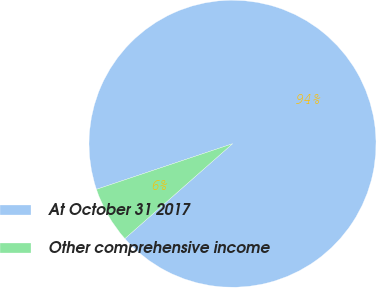Convert chart. <chart><loc_0><loc_0><loc_500><loc_500><pie_chart><fcel>At October 31 2017<fcel>Other comprehensive income<nl><fcel>93.65%<fcel>6.35%<nl></chart> 